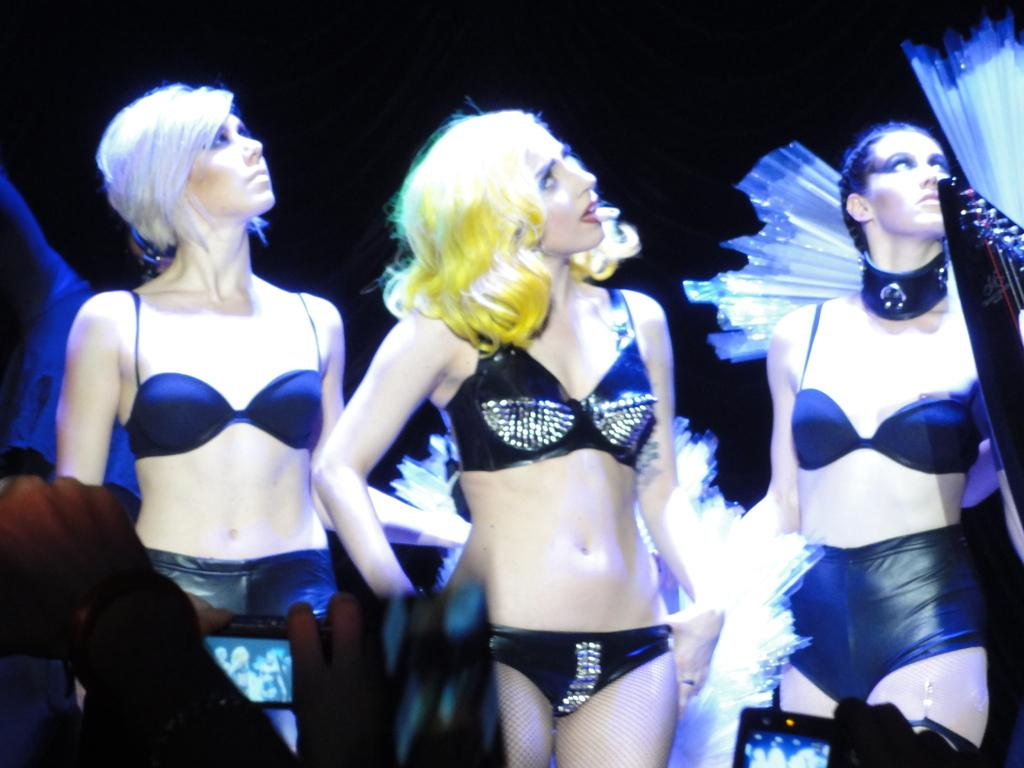Who is present in the image? There are women in the image. What are the women wearing? The women are wearing black dresses. What are the women doing in the image? The women are standing. What is the color of the background in the image? The background color is black. What type of badge can be seen on the women's dresses in the image? There is no badge visible on the women's dresses in the image. How do the women adjust their dresses in the image? The women are not adjusting their dresses in the image; they are standing still. 